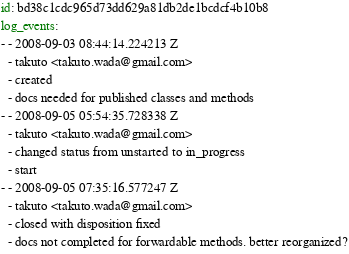Convert code to text. <code><loc_0><loc_0><loc_500><loc_500><_YAML_>
id: bd38c1cdc965d73dd629a81db2de1bcdcf4b10b8
log_events: 
- - 2008-09-03 08:44:14.224213 Z
  - takuto <takuto.wada@gmail.com>
  - created
  - docs needed for published classes and methods
- - 2008-09-05 05:54:35.728338 Z
  - takuto <takuto.wada@gmail.com>
  - changed status from unstarted to in_progress
  - start
- - 2008-09-05 07:35:16.577247 Z
  - takuto <takuto.wada@gmail.com>
  - closed with disposition fixed
  - docs not completed for forwardable methods. better reorganized?
</code> 